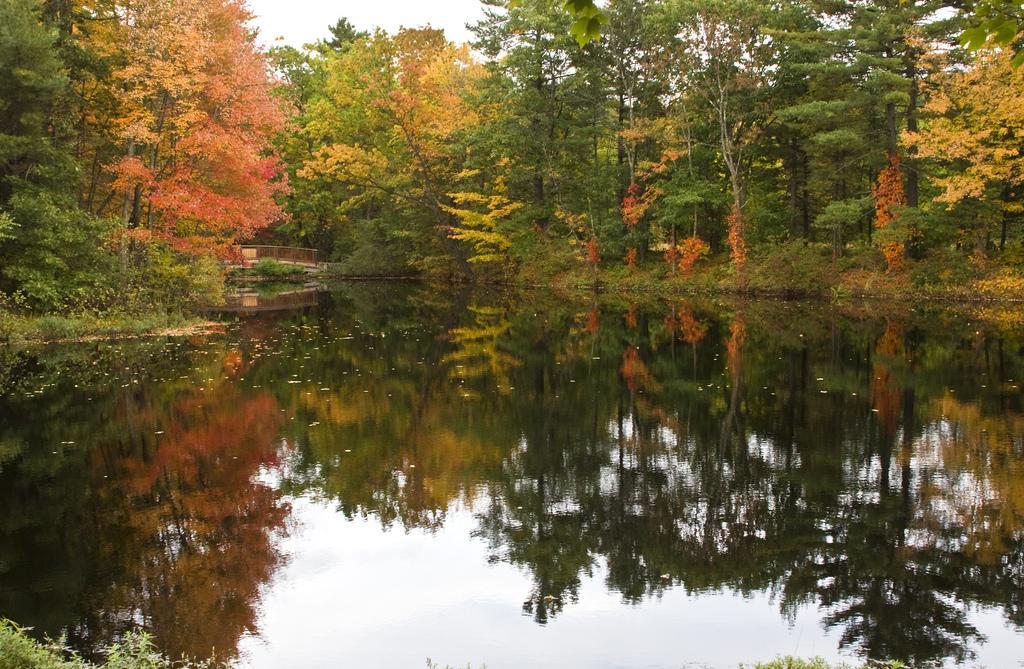Could you give a brief overview of what you see in this image? In this image we can see the water. Behind the water we can see a group of trees, plants and a bridge. At the top we can see the sky. On the water we can see the reflection of trees, plants and the sky. 